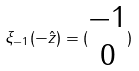Convert formula to latex. <formula><loc_0><loc_0><loc_500><loc_500>\xi _ { - 1 } ( - \hat { z } ) = ( \begin{matrix} - 1 \\ 0 \end{matrix} )</formula> 